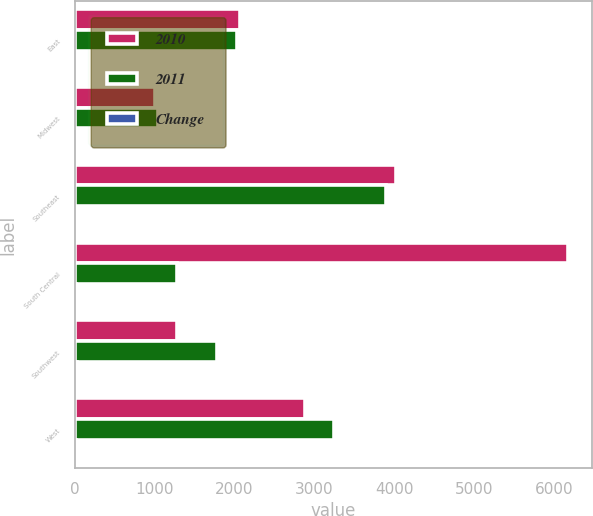<chart> <loc_0><loc_0><loc_500><loc_500><stacked_bar_chart><ecel><fcel>East<fcel>Midwest<fcel>Southeast<fcel>South Central<fcel>Southwest<fcel>West<nl><fcel>2010<fcel>2066<fcel>1005<fcel>4019<fcel>6169<fcel>1284<fcel>2878<nl><fcel>2011<fcel>2027<fcel>1045<fcel>3892<fcel>1284<fcel>1785<fcel>3251<nl><fcel>Change<fcel>2<fcel>4<fcel>3<fcel>16<fcel>28<fcel>11<nl></chart> 